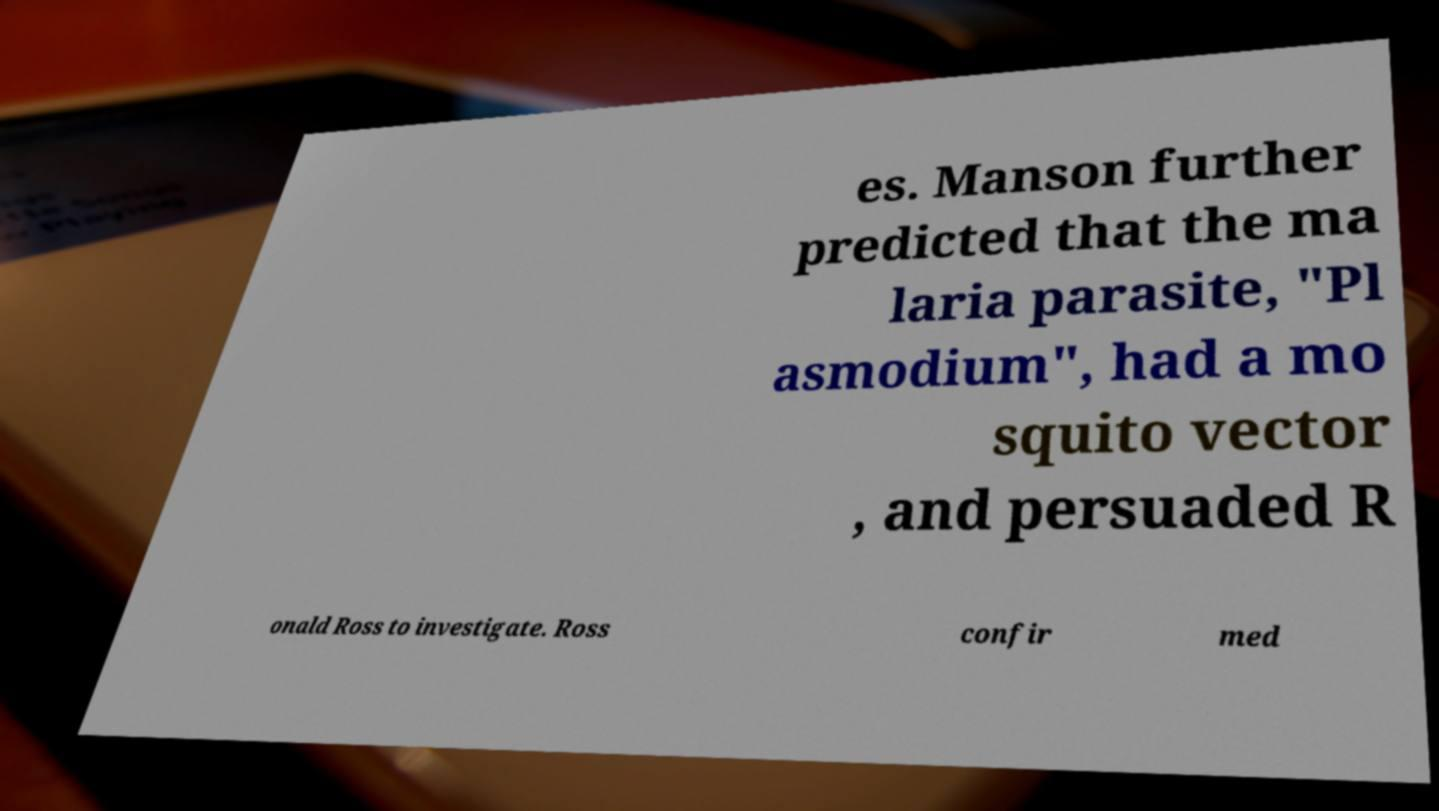Could you extract and type out the text from this image? es. Manson further predicted that the ma laria parasite, "Pl asmodium", had a mo squito vector , and persuaded R onald Ross to investigate. Ross confir med 